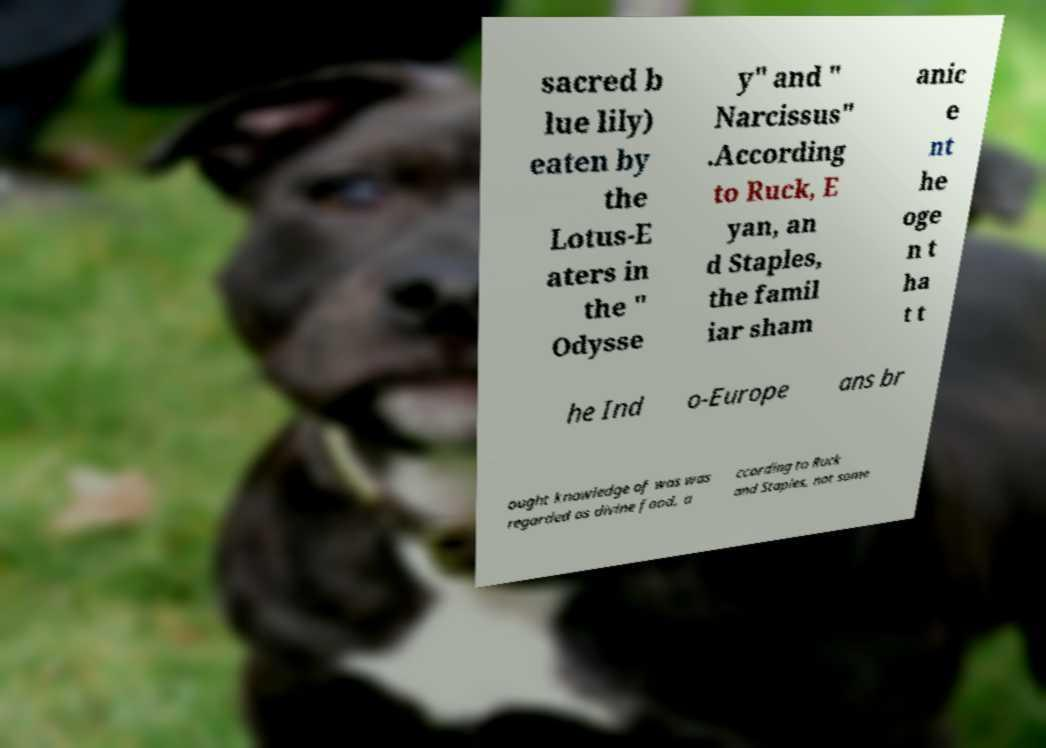Can you accurately transcribe the text from the provided image for me? sacred b lue lily) eaten by the Lotus-E aters in the " Odysse y" and " Narcissus" .According to Ruck, E yan, an d Staples, the famil iar sham anic e nt he oge n t ha t t he Ind o-Europe ans br ought knowledge of was was regarded as divine food, a ccording to Ruck and Staples, not some 